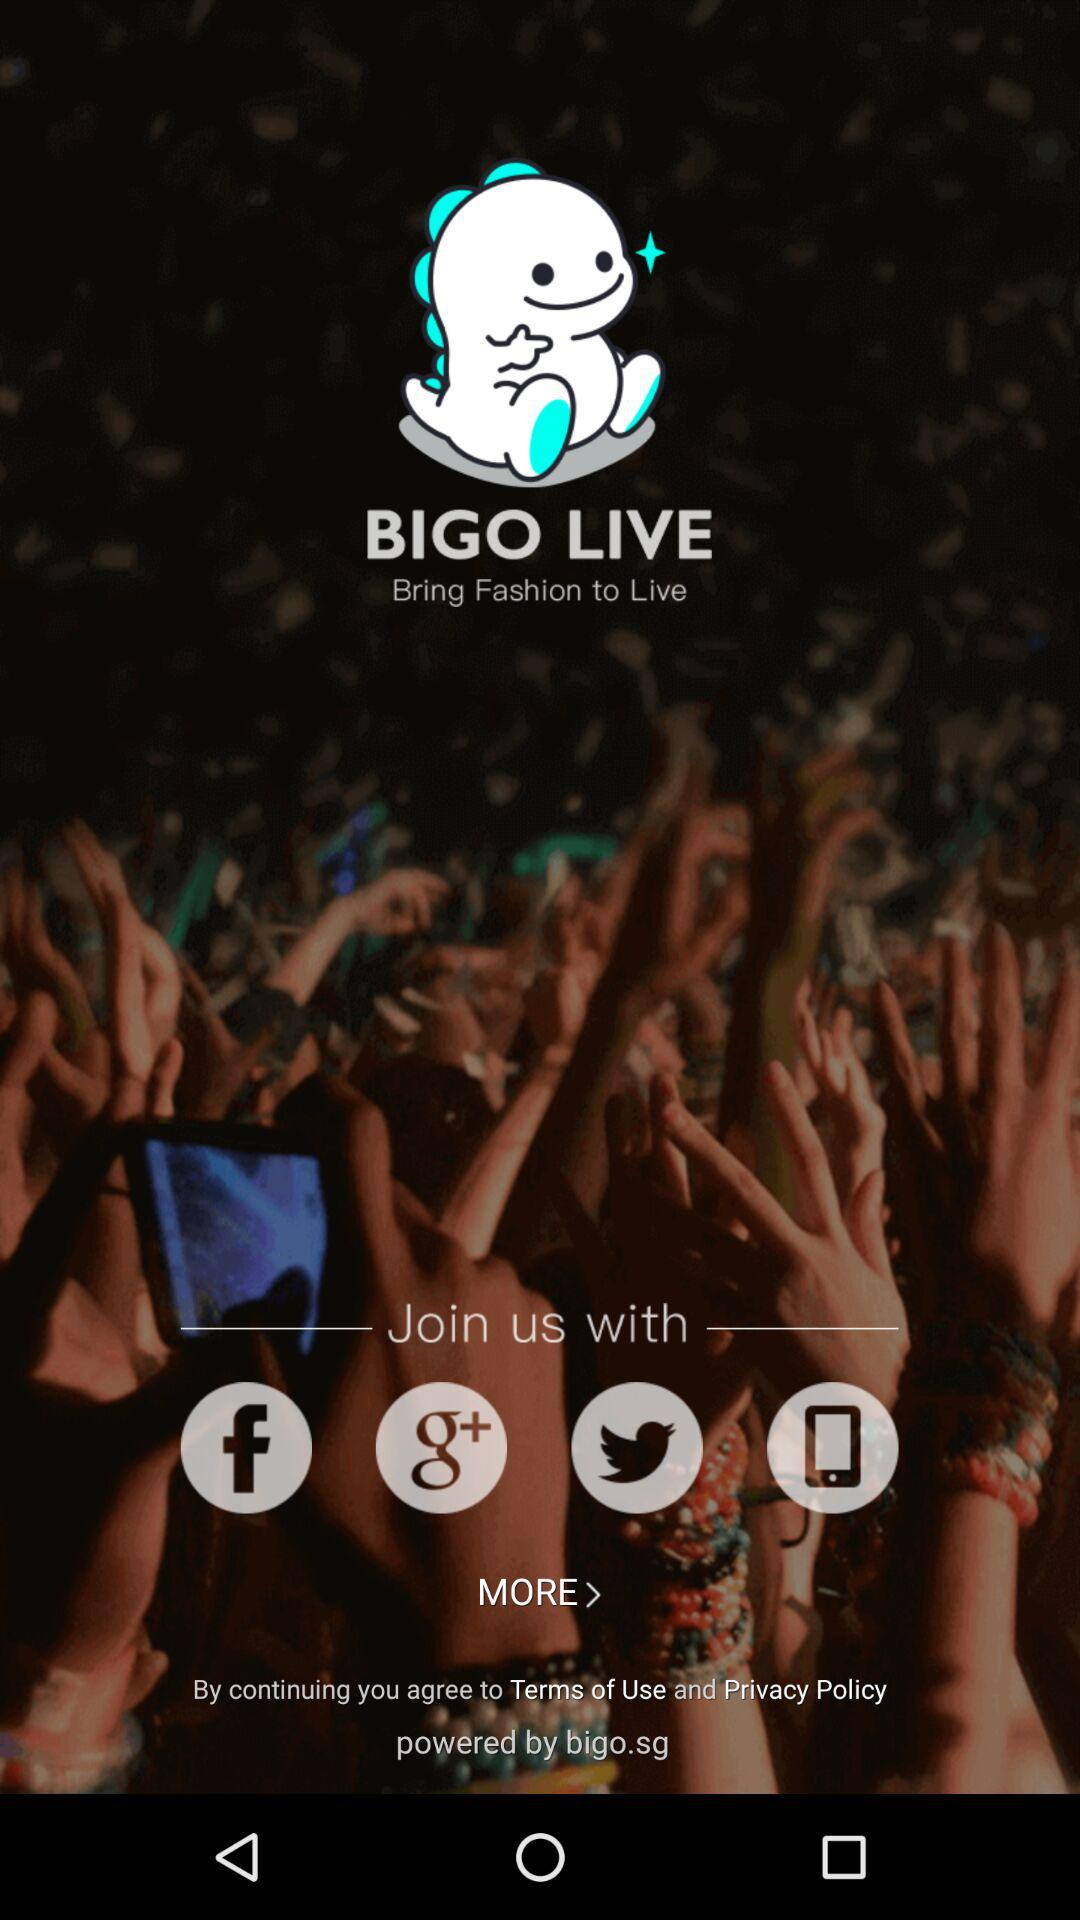What is the name of the application? The name of the application is "BIGO LIVE". 